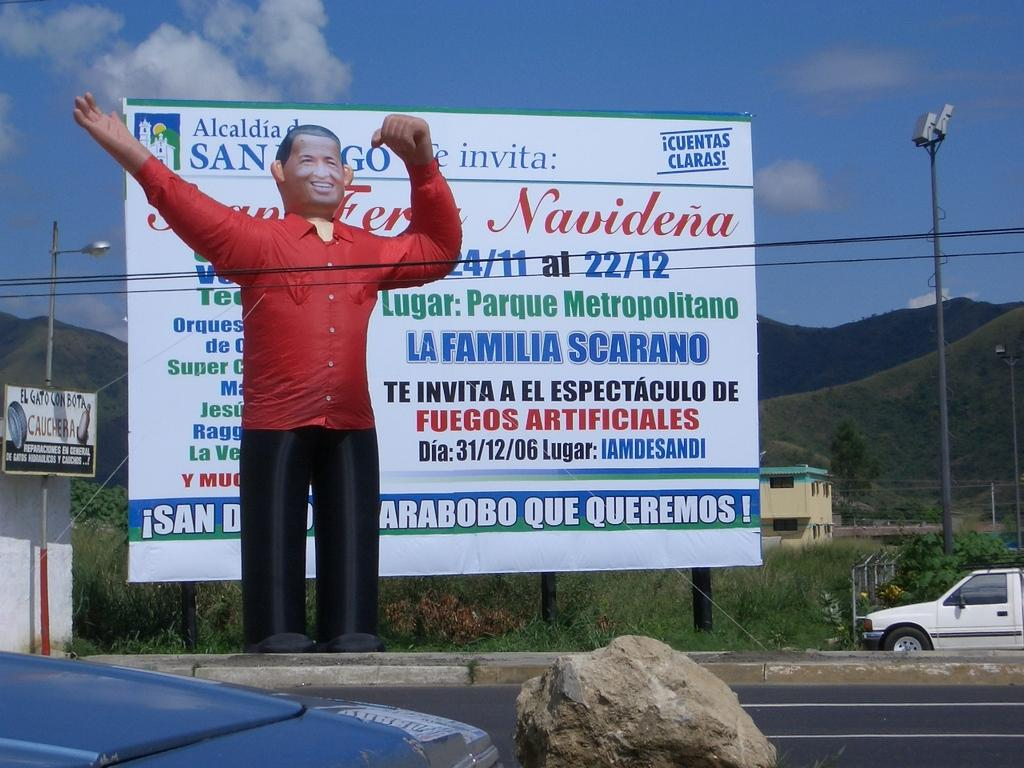<image>
Offer a succinct explanation of the picture presented. A billboard contains information about an event in San Diego. 